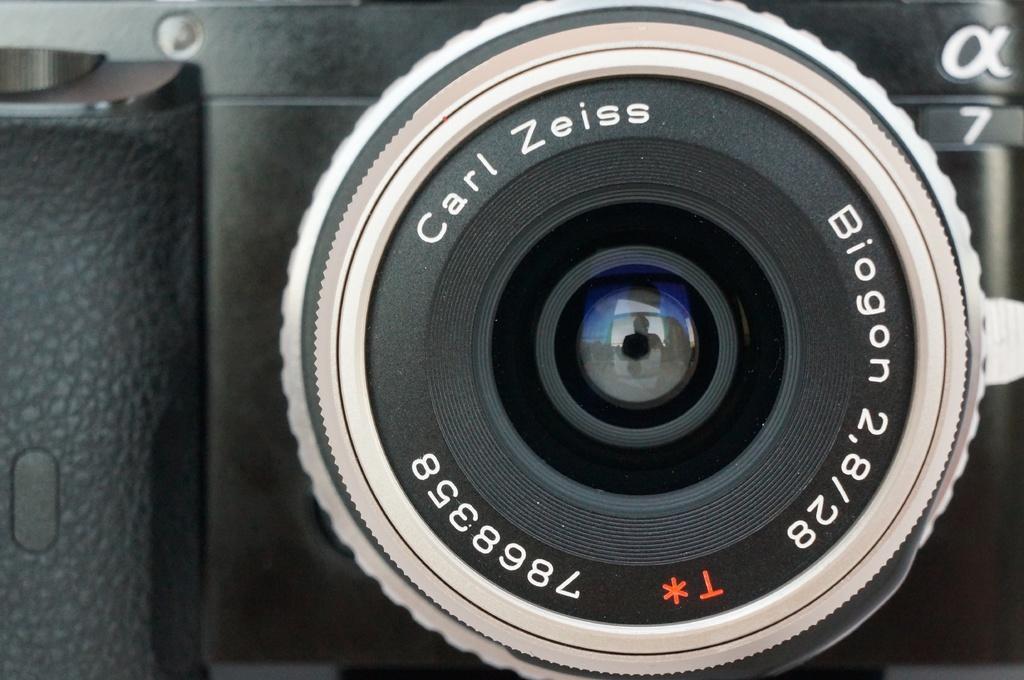Can you describe this image briefly? The picture consists of a camera. In the center of the picture it is camera lens. 